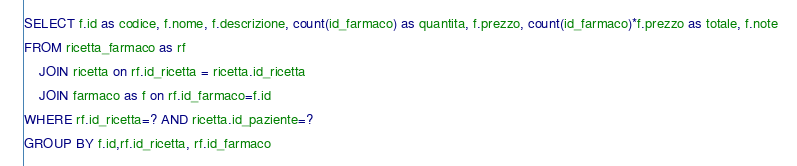<code> <loc_0><loc_0><loc_500><loc_500><_SQL_>SELECT f.id as codice, f.nome, f.descrizione, count(id_farmaco) as quantita, f.prezzo, count(id_farmaco)*f.prezzo as totale, f.note  
FROM ricetta_farmaco as rf
    JOIN ricetta on rf.id_ricetta = ricetta.id_ricetta
    JOIN farmaco as f on rf.id_farmaco=f.id
WHERE rf.id_ricetta=? AND ricetta.id_paziente=?
GROUP BY f.id,rf.id_ricetta, rf.id_farmaco</code> 